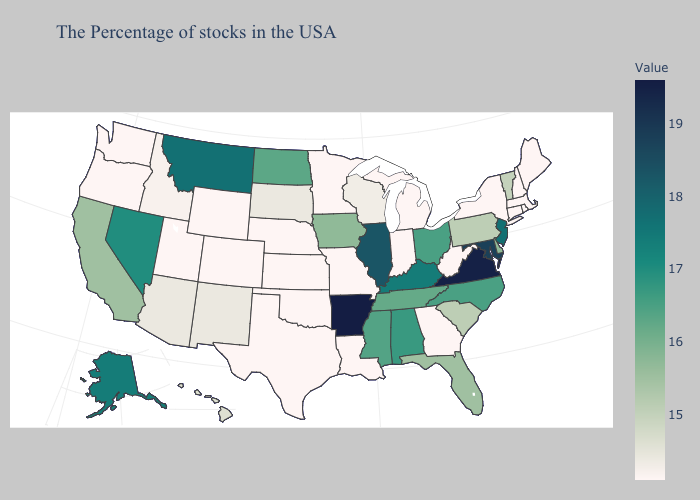Does Massachusetts have the highest value in the Northeast?
Quick response, please. No. Which states have the lowest value in the USA?
Quick response, please. Maine, Massachusetts, Rhode Island, New Hampshire, Connecticut, New York, West Virginia, Georgia, Michigan, Indiana, Louisiana, Missouri, Minnesota, Kansas, Nebraska, Oklahoma, Texas, Wyoming, Colorado, Utah, Washington, Oregon. Which states hav the highest value in the South?
Concise answer only. Arkansas. Does Vermont have the lowest value in the USA?
Short answer required. No. Does New Jersey have the highest value in the Northeast?
Be succinct. Yes. 